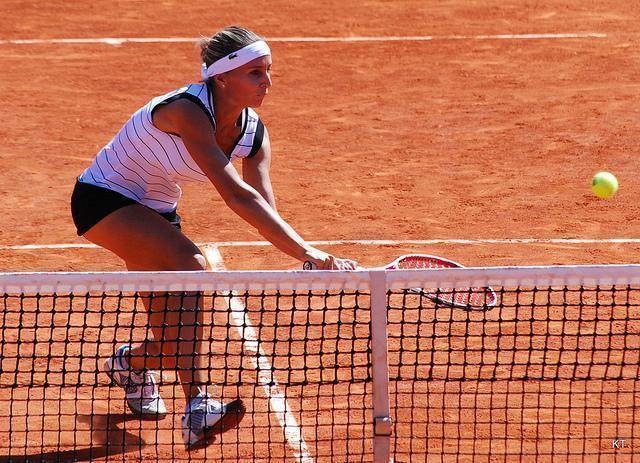How many chairs in this image have visible legs?
Give a very brief answer. 0. 